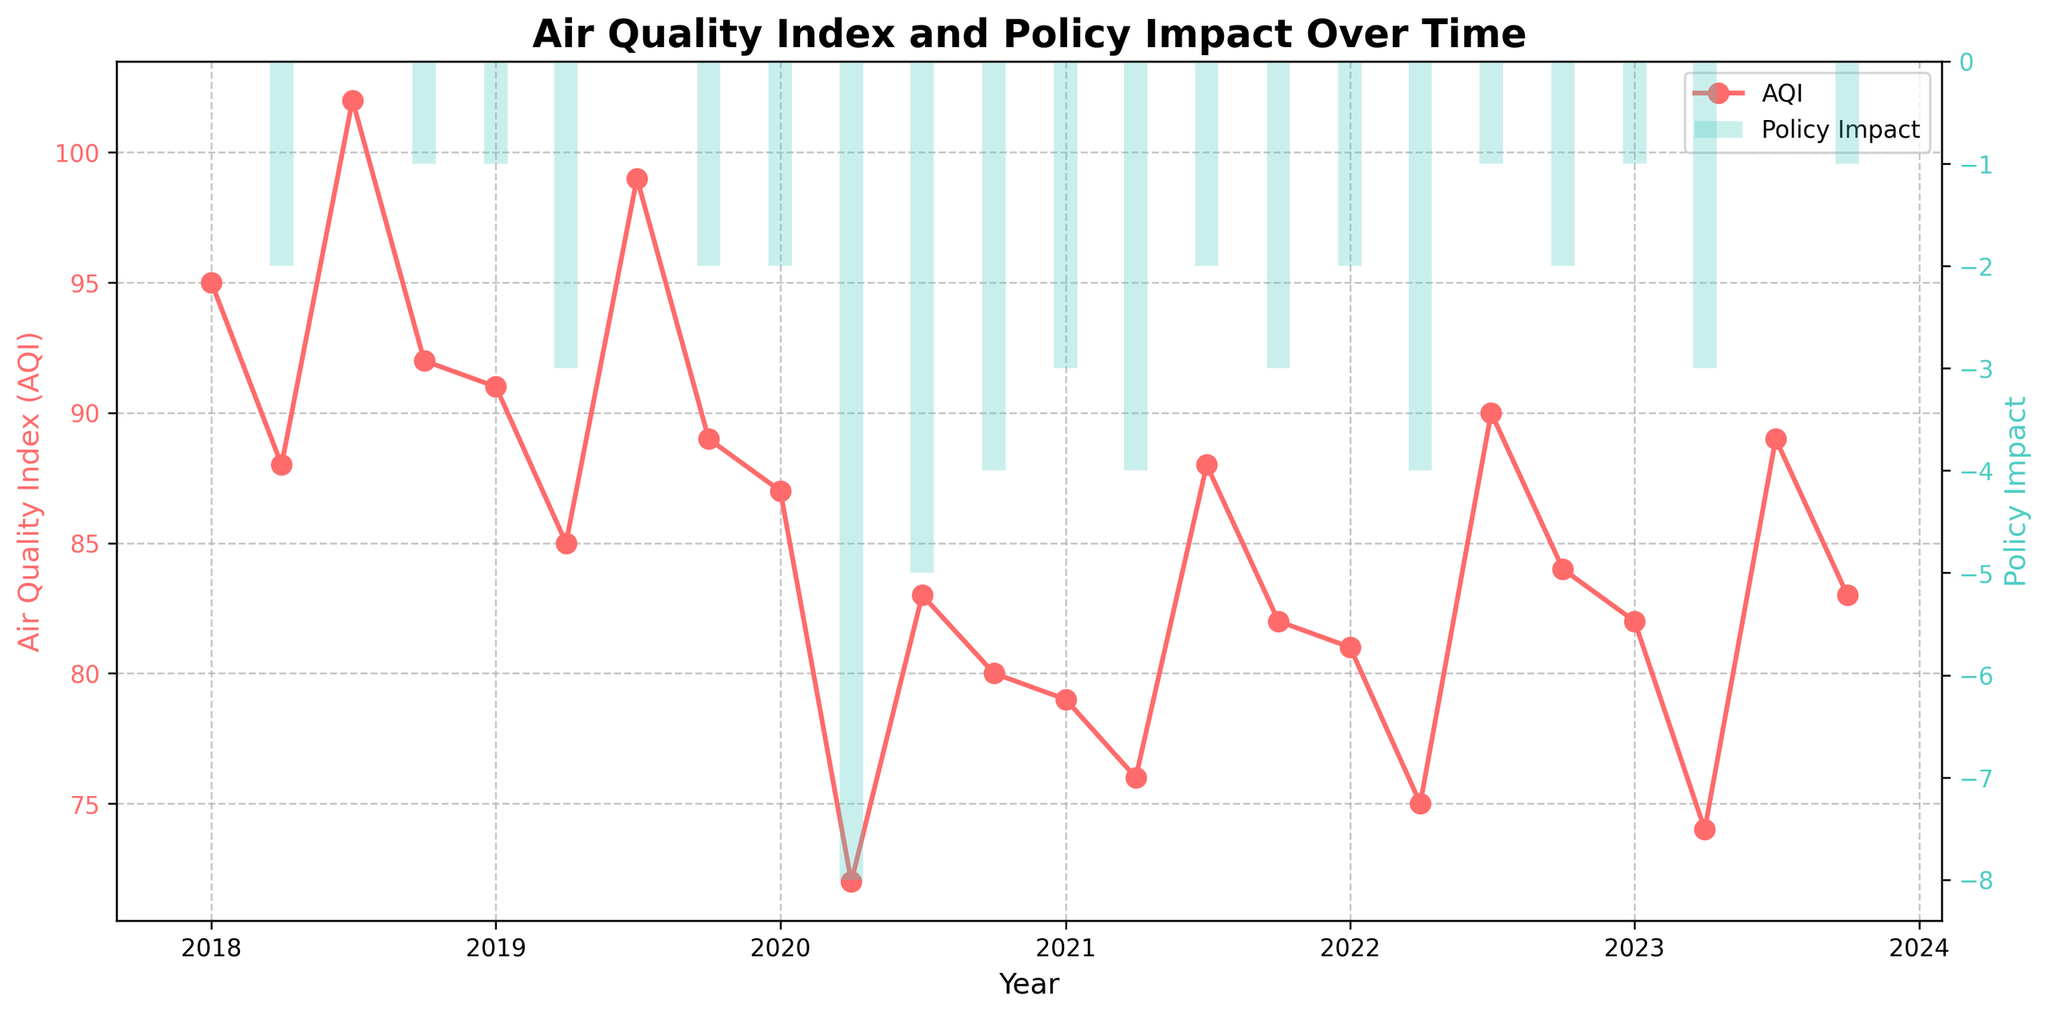What trend do you observe in AQI from 2018 to 2023? The AQI shows a general declining trend over the five years, despite some seasonal fluctuations. This indicates an overall improvement in air quality in the urban centers.
Answer: General declining trend How did the AQI change from the start of 2018 to the start of 2023? The AQI in January 2018 was 95, and it decreased to 82 in January 2023. This represents an overall reduction in AQI over five years.
Answer: It decreased Which year showed the most significant improvement in AQI? The most significant improvement in AQI can be observed in 2020, particularly evident by the sharp drop during the second quarter when the AQI fell from 87 to 72.
Answer: 2020 What months usually show a decrease in AQI? The months of April and October typically show a decrease in AQI compared to the previous months.
Answer: April and October What was the AQI value in July 2020 and how does it compare to July 2019? The AQI in July 2020 was 83, while in July 2019 it was 99. This shows a notable improvement in air quality in July 2020 as compared to July 2019.
Answer: 83 in 2020, 99 in 2019 In which quarter of 2020 did the most drastic AQI improvement occur? The most drastic AQI improvement in 2020 occurred in the second quarter (April), where the AQI dropped from 87 to 72.
Answer: Second quarter (April) How did the policy impact correlate with the change in AQI in 2020? In 2020, particularly in the second quarter (April), a significant drop in AQI is observed alongside a considerable negative policy impact value, indicating successful policy measures.
Answer: Negative correlation Compare the AQI in April 2022 and April 2023. Which year had better air quality? The AQI in April 2022 was 75, while in April 2023 it was 74. Therefore, April 2023 had a slightly better air quality.
Answer: April 2023 Which policy impact was most significant and when did it occur? The most significant policy impact was in April 2020 with a value of -8, indicating strong policy measures that led to a sharp reduction in AQI.
Answer: April 2020, -8 